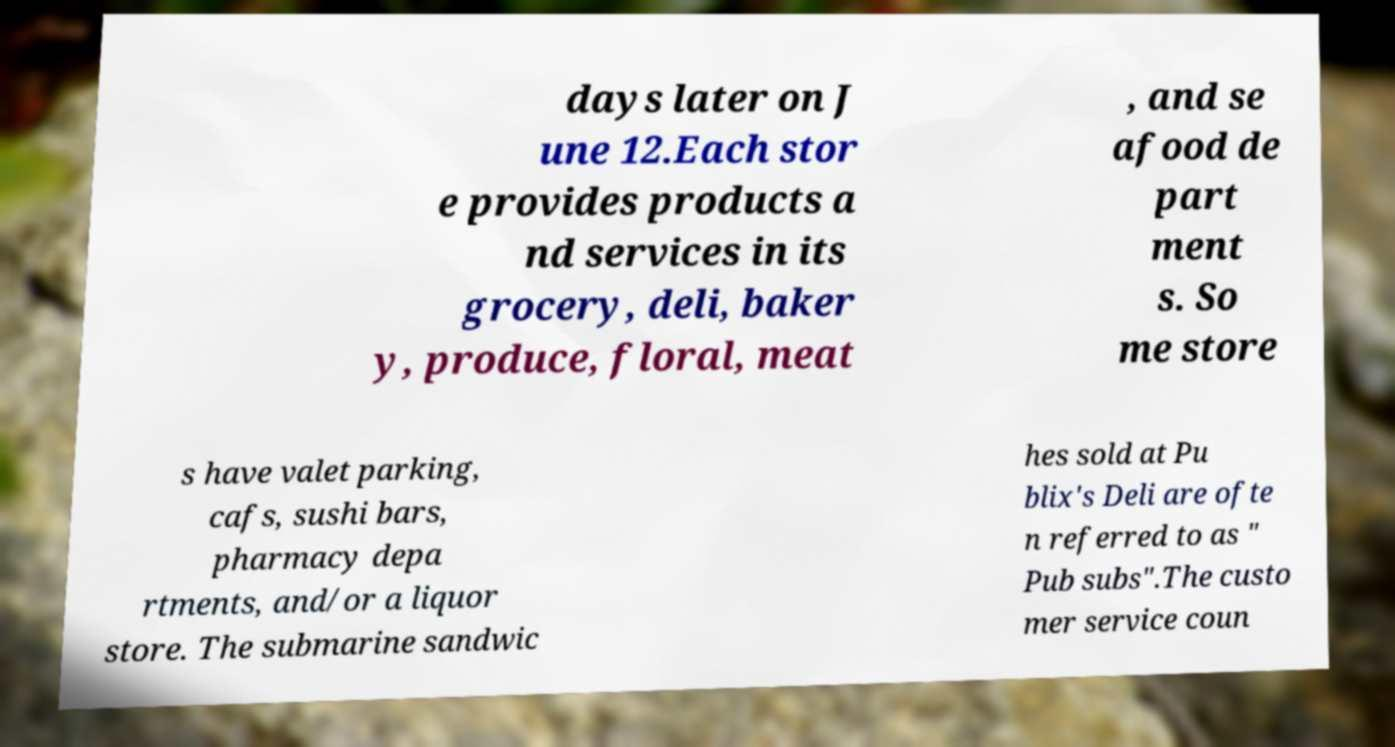Please identify and transcribe the text found in this image. days later on J une 12.Each stor e provides products a nd services in its grocery, deli, baker y, produce, floral, meat , and se afood de part ment s. So me store s have valet parking, cafs, sushi bars, pharmacy depa rtments, and/or a liquor store. The submarine sandwic hes sold at Pu blix's Deli are ofte n referred to as " Pub subs".The custo mer service coun 